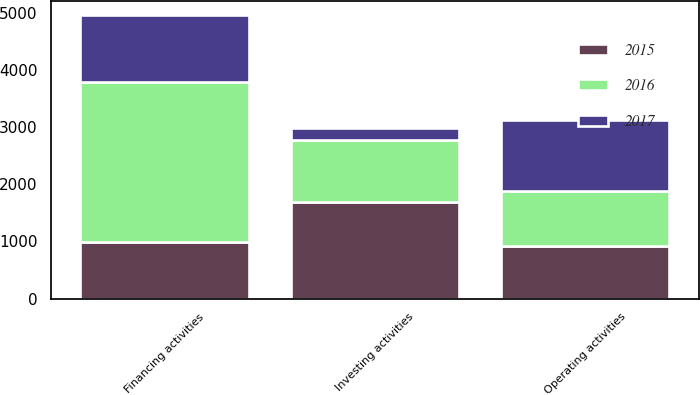Convert chart. <chart><loc_0><loc_0><loc_500><loc_500><stacked_bar_chart><ecel><fcel>Operating activities<fcel>Investing activities<fcel>Financing activities<nl><fcel>2017<fcel>1234<fcel>210<fcel>1170<nl><fcel>2016<fcel>964<fcel>1083<fcel>2805<nl><fcel>2015<fcel>929<fcel>1698<fcel>996<nl></chart> 